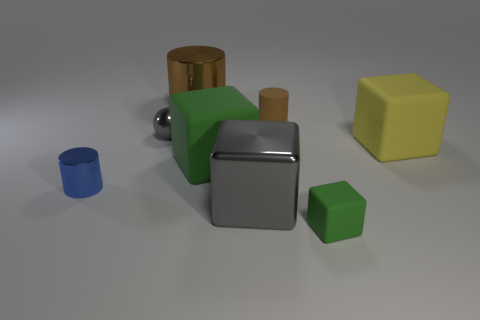Subtract all small brown matte cylinders. How many cylinders are left? 2 Subtract all blue cylinders. How many cylinders are left? 2 Add 1 green matte balls. How many objects exist? 9 Subtract all balls. How many objects are left? 7 Subtract 3 blocks. How many blocks are left? 1 Subtract all gray balls. How many green blocks are left? 2 Add 6 blue cylinders. How many blue cylinders are left? 7 Add 1 blue cylinders. How many blue cylinders exist? 2 Subtract 0 purple spheres. How many objects are left? 8 Subtract all green blocks. Subtract all blue spheres. How many blocks are left? 2 